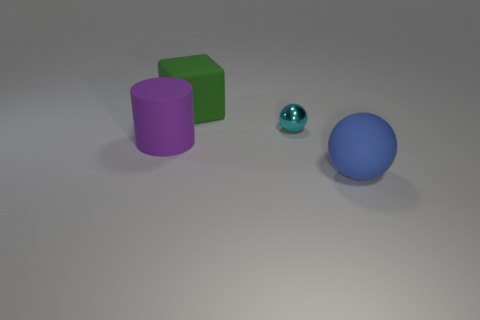Subtract all green cylinders. Subtract all purple blocks. How many cylinders are left? 1 Add 3 tiny purple cubes. How many objects exist? 7 Subtract all cylinders. How many objects are left? 3 Subtract 0 brown spheres. How many objects are left? 4 Subtract all purple rubber spheres. Subtract all large blue rubber balls. How many objects are left? 3 Add 3 large green cubes. How many large green cubes are left? 4 Add 4 cyan metal things. How many cyan metal things exist? 5 